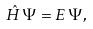Convert formula to latex. <formula><loc_0><loc_0><loc_500><loc_500>\hat { H } \, \Psi = E \, \Psi ,</formula> 